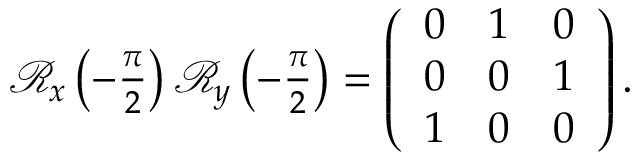Convert formula to latex. <formula><loc_0><loc_0><loc_500><loc_500>\begin{array} { r } { \mathcal { R } _ { x } \left ( - \frac { \pi } { 2 } \right ) \mathcal { R } _ { y } \left ( - \frac { \pi } { 2 } \right ) = \left ( \begin{array} { c c c } { 0 } & { 1 } & { 0 } \\ { 0 } & { 0 } & { 1 } \\ { 1 } & { 0 } & { 0 } \end{array} \right ) . } \end{array}</formula> 